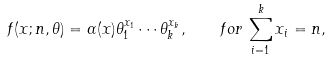Convert formula to latex. <formula><loc_0><loc_0><loc_500><loc_500>f ( x ; n , \theta ) = \alpha ( x ) \theta _ { 1 } ^ { x _ { 1 } } \cdots \theta _ { k } ^ { x _ { k } } , \quad f o r \, \sum _ { i = 1 } ^ { k } x _ { i } = n ,</formula> 